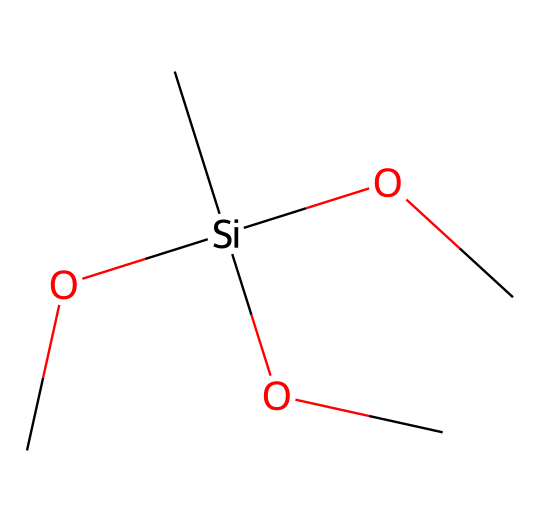What is the chemical formula of this compound? To determine the chemical formula from the SMILES representation, we can break down the components. The SMILES shows one silicon (Si), four carbons (C), and twelve hydrogens (H) through the branching methyl (C) groups and bonded oxygens (O). Therefore, the total formula is C4H12O3Si.
Answer: C4H12O3Si How many oxygen atoms are present in this compound? By examining the SMILES notation, we can see that there are three instances of oxygen (O) connected to the silicon and carbon atoms.
Answer: 3 What type of chemical is this SMILES representation classified as? The SMILES represents an organosilane due to the presence of silicon atoms bonded to organic groups, specifically methyl groups (C) and oxygens (O).
Answer: organosilane What is the total number of atoms in this molecule? To find the total number of atoms, we count all the atoms from the chemical formula derived earlier (C4H12O3Si), which gives us a total of 4 (C) + 12 (H) + 3 (O) + 1 (Si) = 20 atoms.
Answer: 20 What is the main functional group in this compound? The presence of multiple alkoxy (OC) groups connected to silicon indicates that the main functional group is an alkoxy group, which is key for the properties of organosilanes, particularly for preservation materials.
Answer: alkoxy 